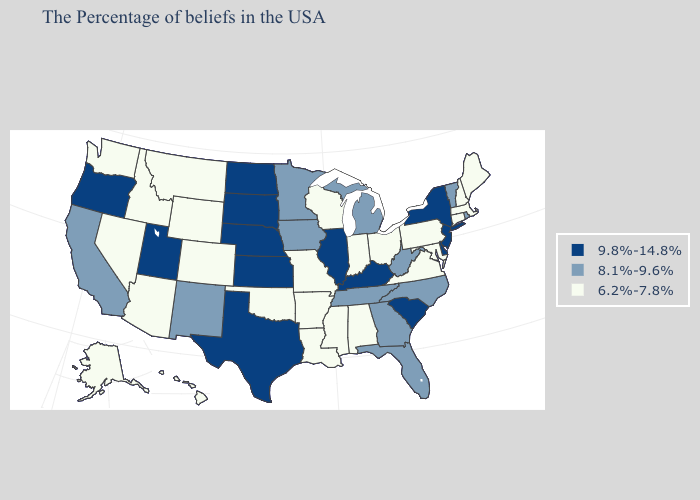Does Oklahoma have the lowest value in the South?
Short answer required. Yes. Name the states that have a value in the range 8.1%-9.6%?
Give a very brief answer. Rhode Island, Vermont, North Carolina, West Virginia, Florida, Georgia, Michigan, Tennessee, Minnesota, Iowa, New Mexico, California. Name the states that have a value in the range 9.8%-14.8%?
Write a very short answer. New York, New Jersey, Delaware, South Carolina, Kentucky, Illinois, Kansas, Nebraska, Texas, South Dakota, North Dakota, Utah, Oregon. Does Colorado have the lowest value in the USA?
Answer briefly. Yes. What is the value of Nevada?
Give a very brief answer. 6.2%-7.8%. Does Texas have the same value as Rhode Island?
Short answer required. No. Does Georgia have a lower value than West Virginia?
Concise answer only. No. What is the lowest value in states that border Oklahoma?
Concise answer only. 6.2%-7.8%. Among the states that border North Carolina , which have the lowest value?
Keep it brief. Virginia. Does Oklahoma have the lowest value in the South?
Write a very short answer. Yes. Name the states that have a value in the range 9.8%-14.8%?
Give a very brief answer. New York, New Jersey, Delaware, South Carolina, Kentucky, Illinois, Kansas, Nebraska, Texas, South Dakota, North Dakota, Utah, Oregon. Among the states that border Alabama , does Georgia have the lowest value?
Answer briefly. No. What is the highest value in the USA?
Short answer required. 9.8%-14.8%. Does the map have missing data?
Give a very brief answer. No. 